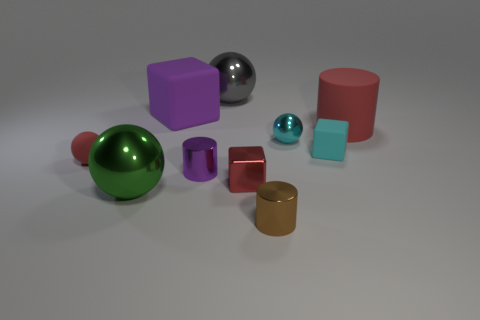Does the cylinder behind the small purple metal cylinder have the same color as the tiny rubber sphere?
Ensure brevity in your answer.  Yes. How many small red things are the same shape as the purple matte thing?
Your answer should be compact. 1. What number of objects are either large spheres that are in front of the big rubber cylinder or metal spheres that are in front of the small red sphere?
Your answer should be very brief. 1. How many cyan objects are either large matte cubes or spheres?
Your response must be concise. 1. What material is the tiny object that is both on the left side of the small cyan cube and on the right side of the small brown metal thing?
Ensure brevity in your answer.  Metal. Are the small purple object and the large red cylinder made of the same material?
Give a very brief answer. No. How many cyan cubes have the same size as the matte sphere?
Offer a terse response. 1. Are there an equal number of gray objects that are to the right of the tiny brown object and small yellow metal cubes?
Offer a terse response. Yes. What number of shiny spheres are behind the small red matte thing and to the left of the small metallic cube?
Provide a succinct answer. 1. Do the big thing that is in front of the red matte cylinder and the gray metal thing have the same shape?
Provide a succinct answer. Yes. 